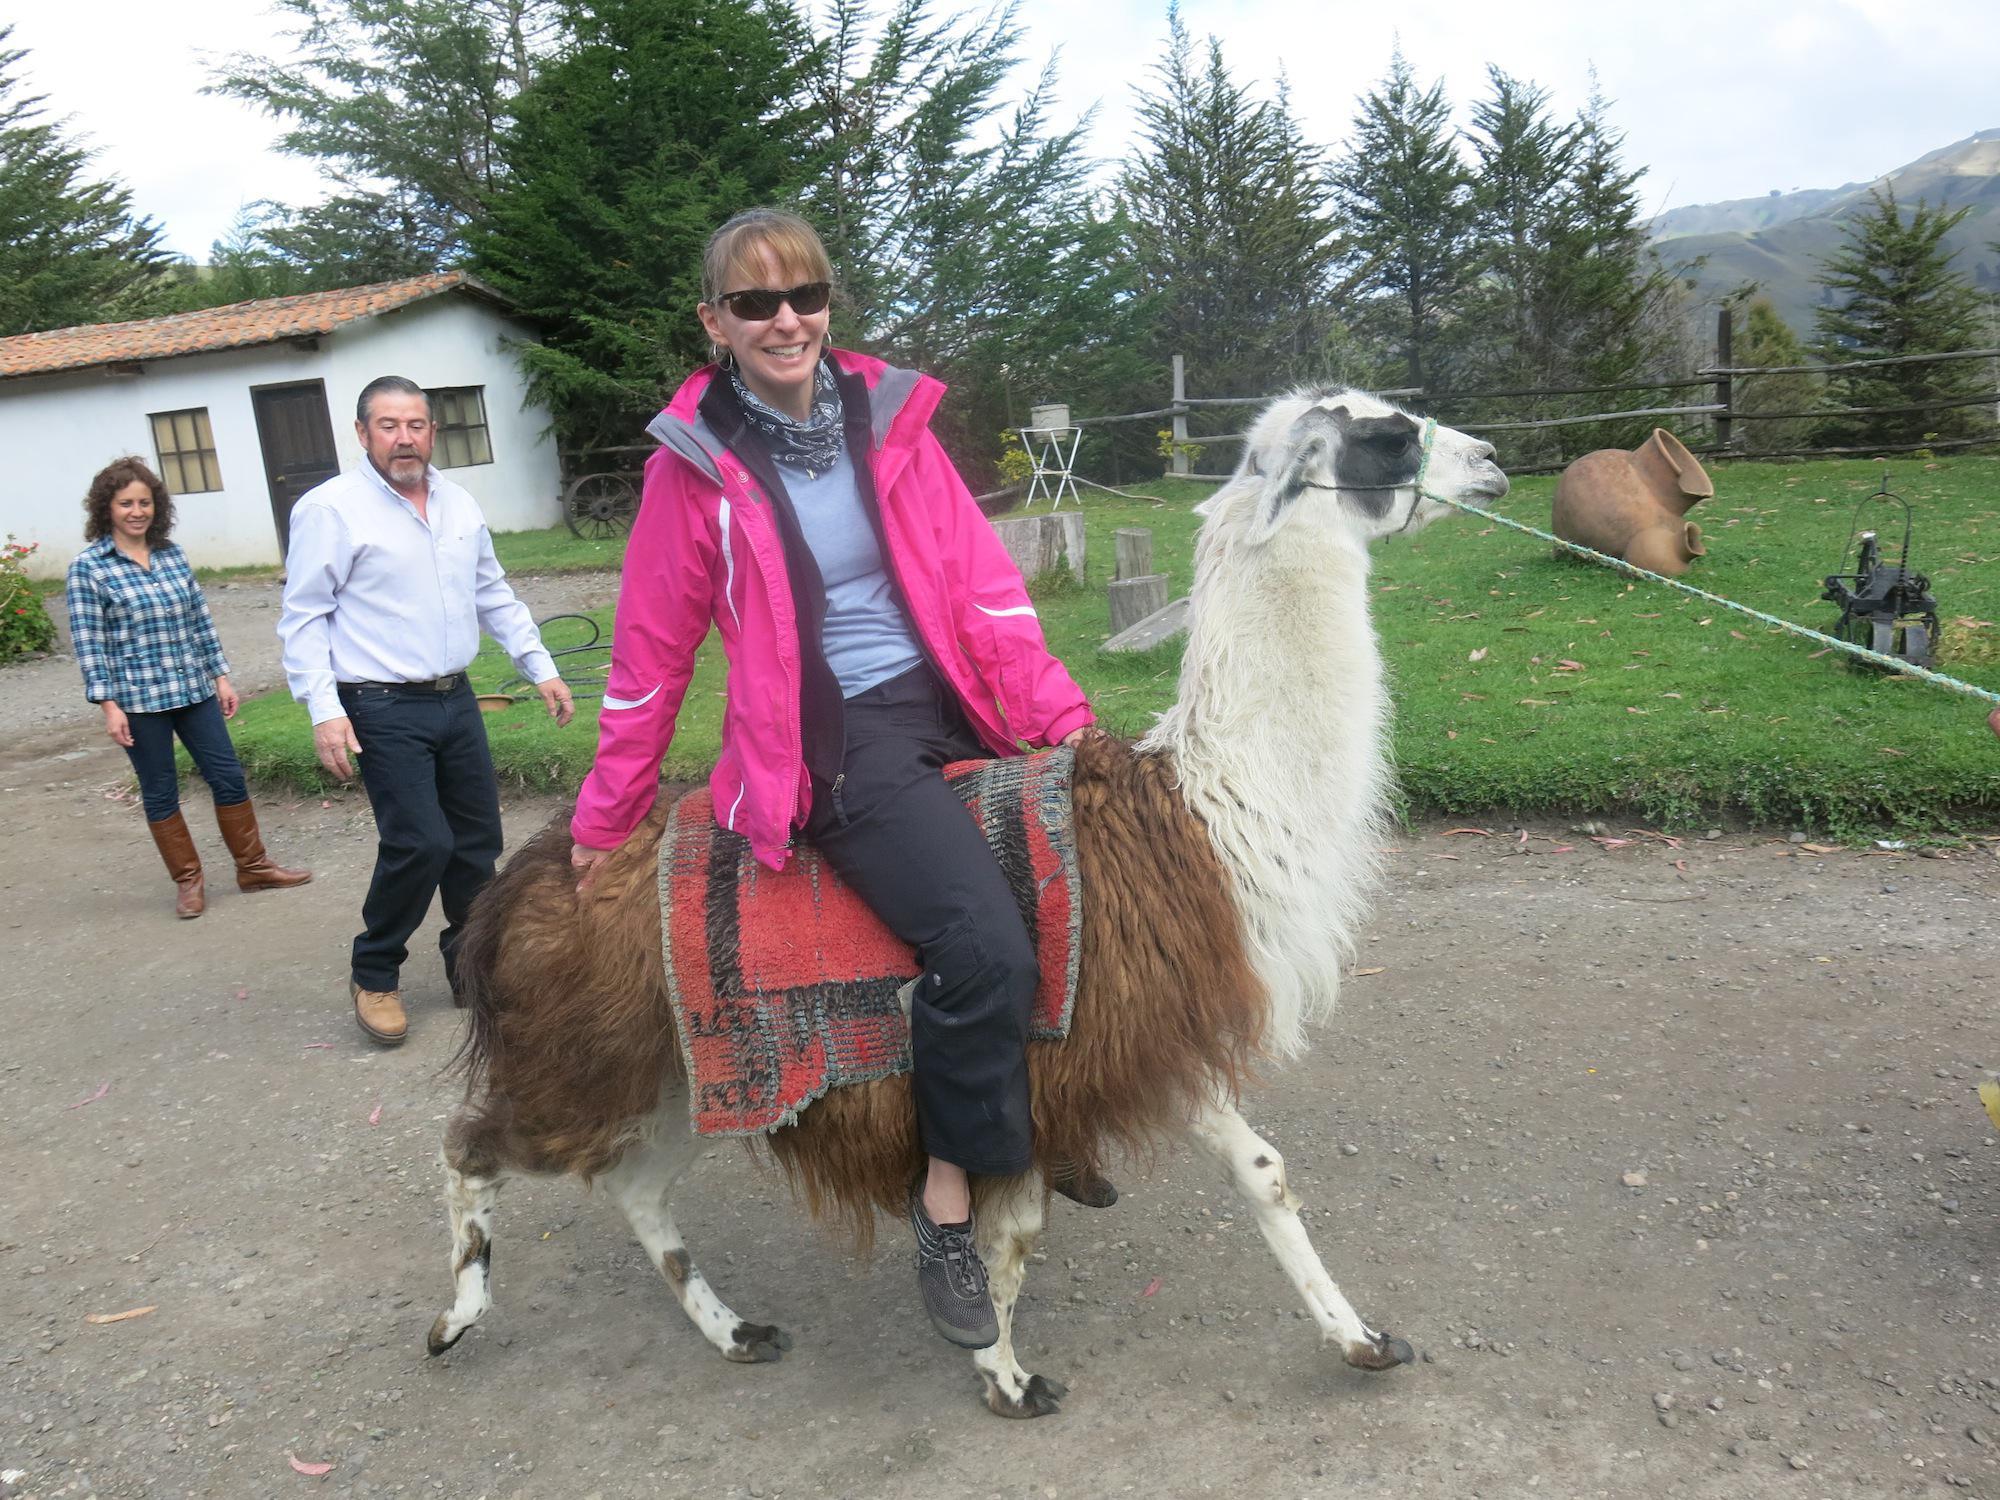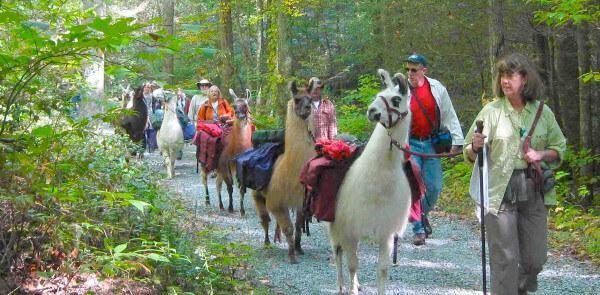The first image is the image on the left, the second image is the image on the right. Assess this claim about the two images: "There are humans riding the llamas.". Correct or not? Answer yes or no. Yes. The first image is the image on the left, the second image is the image on the right. Analyze the images presented: Is the assertion "At least one person can be seen riding a llama." valid? Answer yes or no. Yes. 